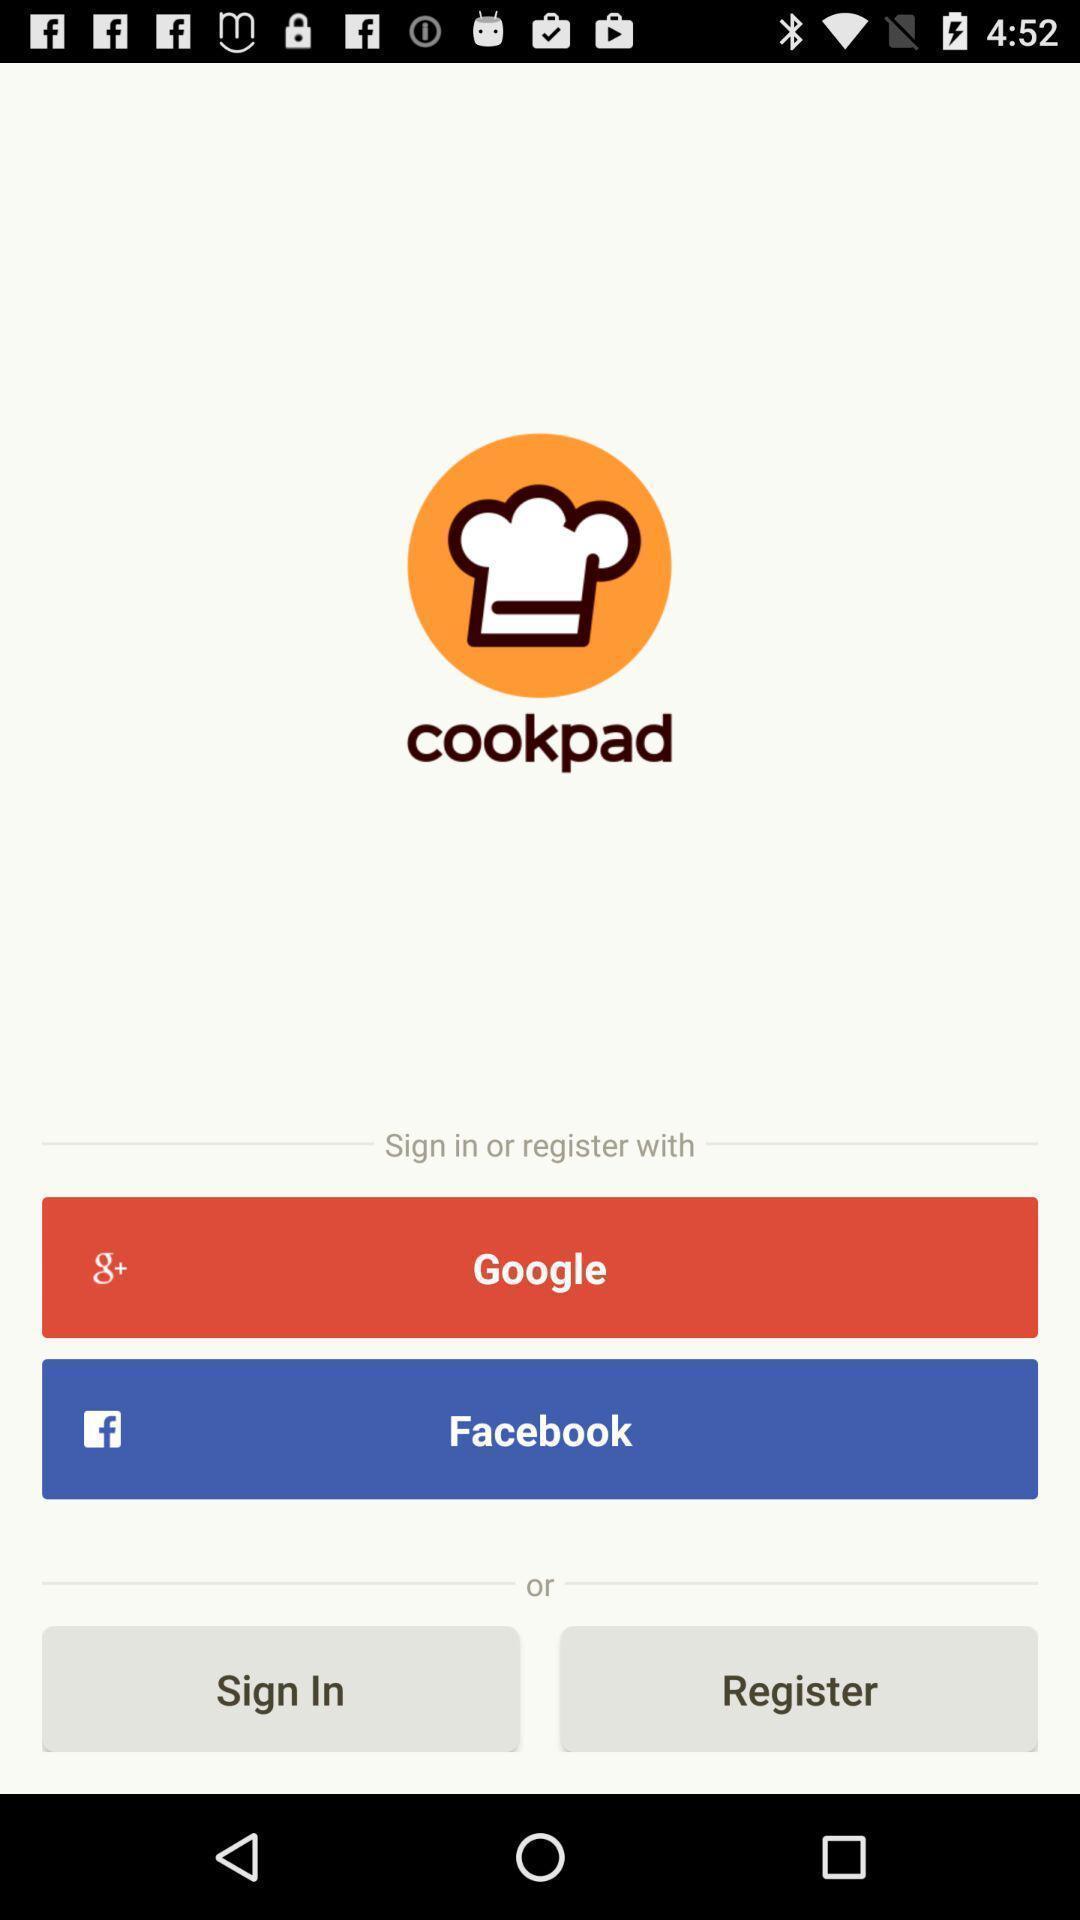Describe the key features of this screenshot. Welcome page with different options. 